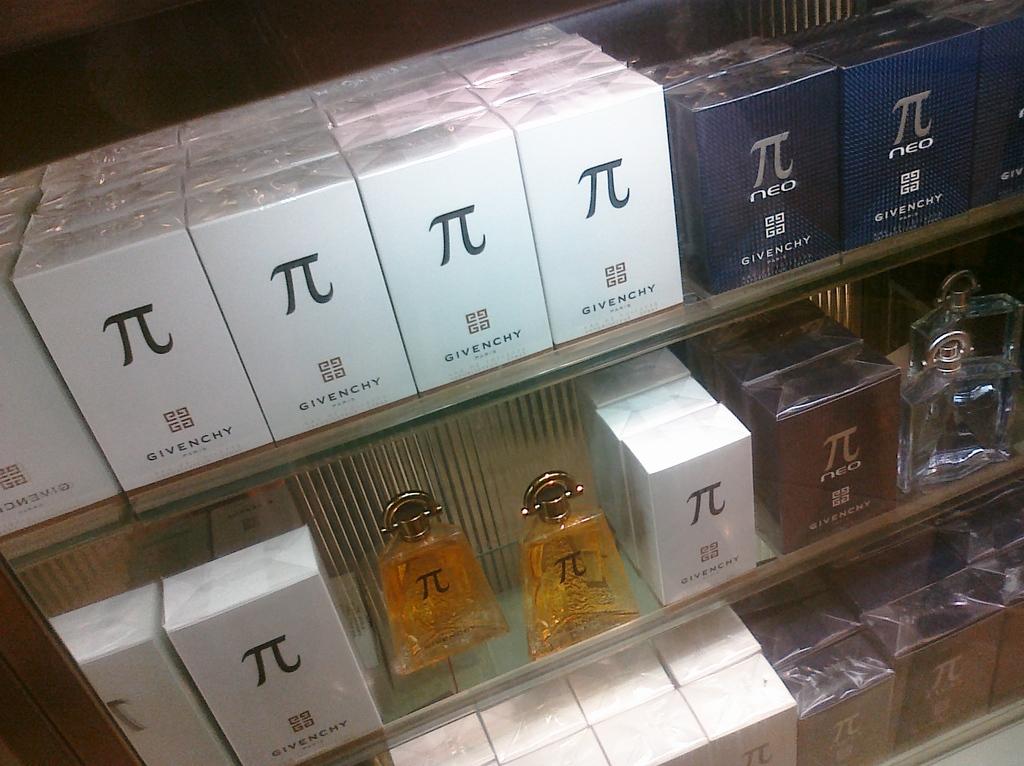What brand makes the product in the white box?
Your answer should be very brief. Givenchy. Which greek symbol is displayed on these boxes?
Keep it short and to the point. Unanswerable. 